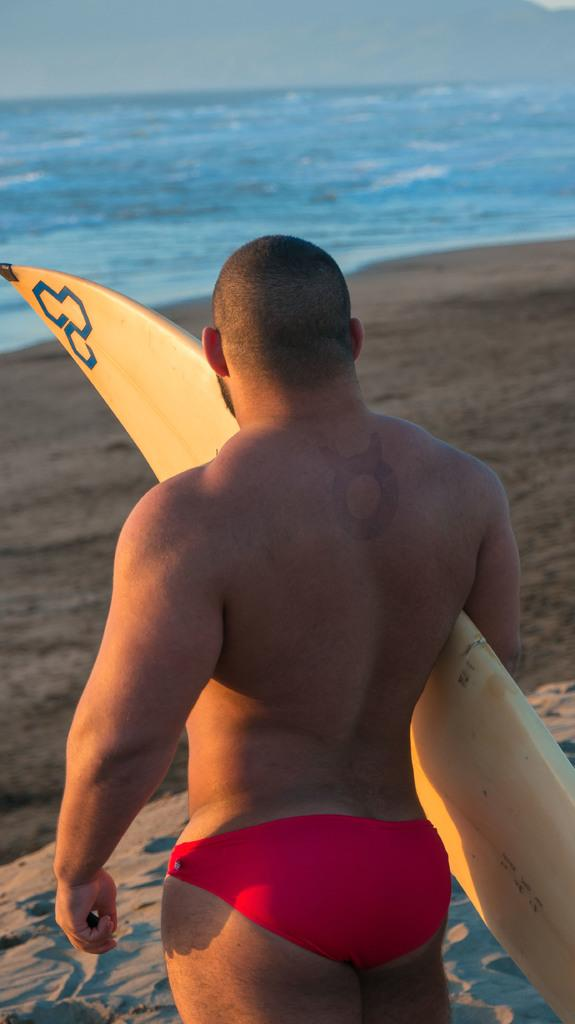Who is present in the image? There is a person in the image. What is the person holding in the image? The person is holding a surfing board. What type of environment is visible in the image? There is water and the sky visible in the image. What color is the balloon floating above the person in the image? There is no balloon present in the image. What type of board is the person using to process data in the image? The person is not using the surfing board to process data; it is used for surfing. 